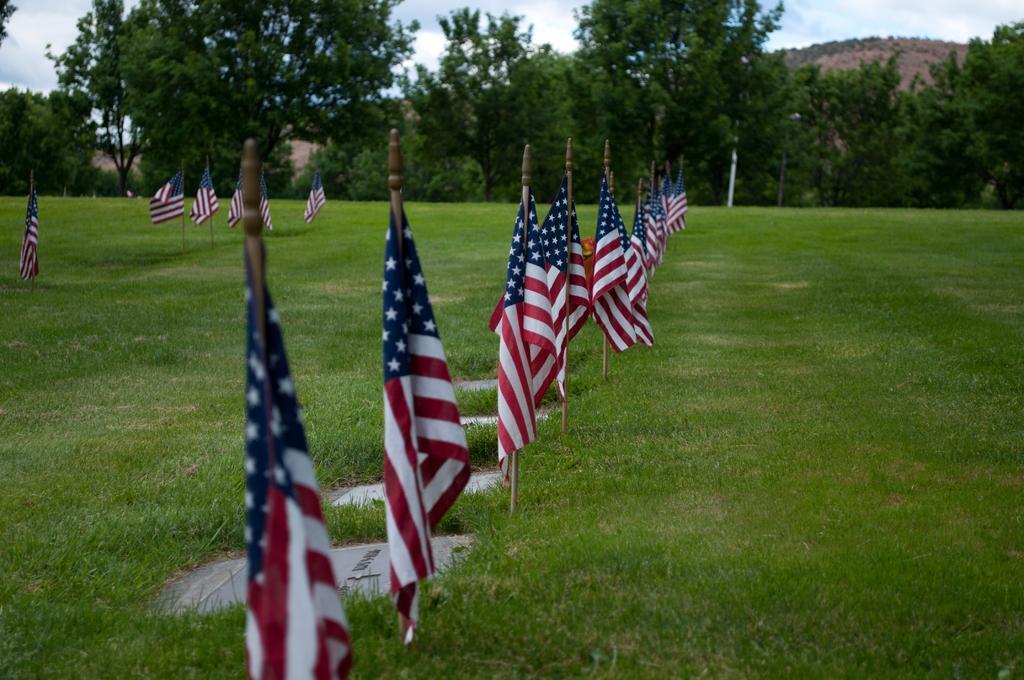Please provide a concise description of this image. In this image there is a ground. There is green grass on the ground. There are flags to the poles. In the background there are trees and mountains. At the top there is the sky. 